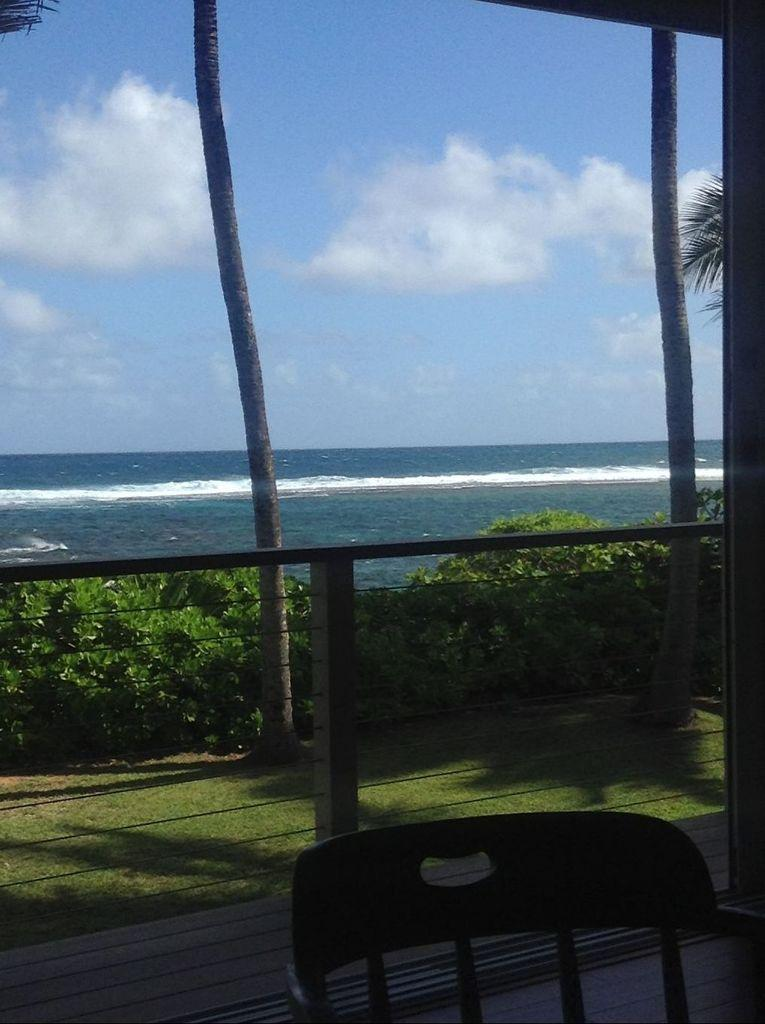What type of furniture is present in the image? There is a chair in the image. What can be seen near the chair? There is a railing in the image. What is located behind the railing? Plants and trees are located behind the railing. What is visible in the background of the image? There is an ocean and a sky with clouds in the background of the image. How many jellyfish are swimming in the ocean in the image? There are no jellyfish visible in the image; it only shows an ocean in the background. What route is the chair taking in the image? The chair is not taking any route, as it is stationary furniture and not a moving object. 